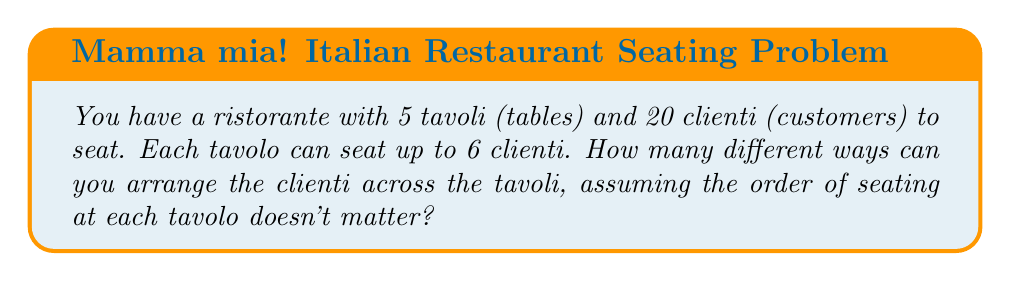Teach me how to tackle this problem. Let's approach this step-by-step, using the concept of partitions in discrete mathematics:

1) First, we need to find all possible ways to distribute 20 clienti across 5 tavoli, where each tavolo can have 0 to 6 clienti. This is equivalent to finding the number of partitions of 20 into 5 parts, where each part is at most 6.

2) We can use the generating function method to solve this. Let's define our generating function:

   $$G(x) = (1 + x + x^2 + x^3 + x^4 + x^5 + x^6)^5$$

3) The coefficient of $x^{20}$ in the expansion of $G(x)$ will give us the number of ways to distribute the clienti.

4) Expanding this polynomial is complex, so we can use the stars and bars method with restrictions:

   $$\sum_{i=0}^5 (-1)^i \binom{5}{i} \binom{20 + 5 - 1 - 7i}{5 - 1}$$

5) Let's calculate each term:
   For $i = 0$: $\binom{5}{0} \binom{24}{4} = 1 \cdot 10626 = 10626$
   For $i = 1$: $\binom{5}{1} \binom{17}{4} = 5 \cdot 2380 = 11900$
   For $i = 2$: $\binom{5}{2} \binom{10}{4} = 10 \cdot 210 = 2100$
   For $i = 3$: $\binom{5}{3} \binom{3}{4} = 10 \cdot 0 = 0$
   For $i = 4$ and $i = 5$, the binomial coefficients are 0.

6) Summing these up with alternating signs:
   $10626 - 11900 + 2100 = 826$

Therefore, there are 826 different ways to arrange the clienti across the tavoli.
Answer: 826 